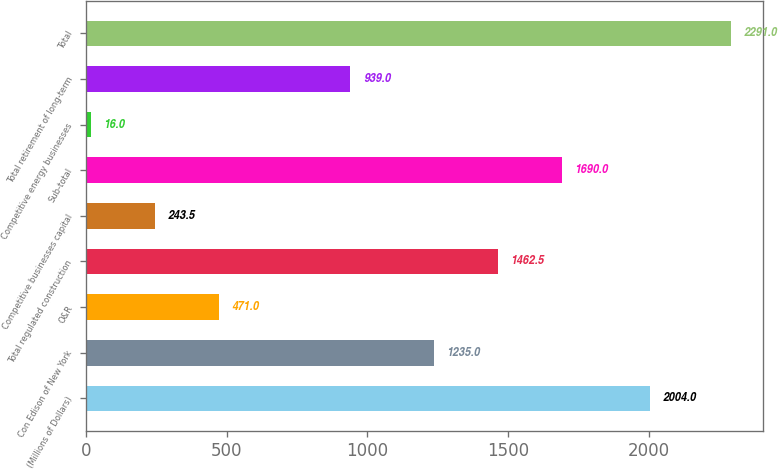Convert chart. <chart><loc_0><loc_0><loc_500><loc_500><bar_chart><fcel>(Millions of Dollars)<fcel>Con Edison of New York<fcel>O&R<fcel>Total regulated construction<fcel>Competitive businesses capital<fcel>Sub-total<fcel>Competitive energy businesses<fcel>Total retirement of long-term<fcel>Total<nl><fcel>2004<fcel>1235<fcel>471<fcel>1462.5<fcel>243.5<fcel>1690<fcel>16<fcel>939<fcel>2291<nl></chart> 